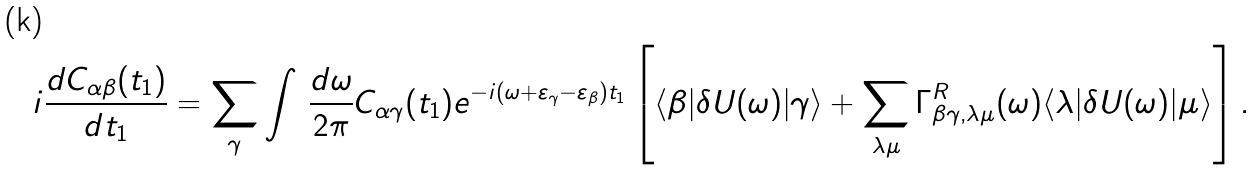<formula> <loc_0><loc_0><loc_500><loc_500>i \frac { d C _ { \alpha \beta } ( t _ { 1 } ) } { d t _ { 1 } } & = \sum _ { \gamma } \int \, \frac { d \omega } { 2 \pi } C _ { \alpha \gamma } ( t _ { 1 } ) e ^ { - i ( \omega + \varepsilon _ { \gamma } - \varepsilon _ { \beta } ) t _ { 1 } } \left [ \langle \beta | \delta U ( \omega ) | \gamma \rangle + \sum _ { \lambda \mu } \Gamma ^ { R } _ { \beta \gamma , \lambda \mu } ( \omega ) \langle \lambda | \delta U ( \omega ) | \mu \rangle \right ] .</formula> 